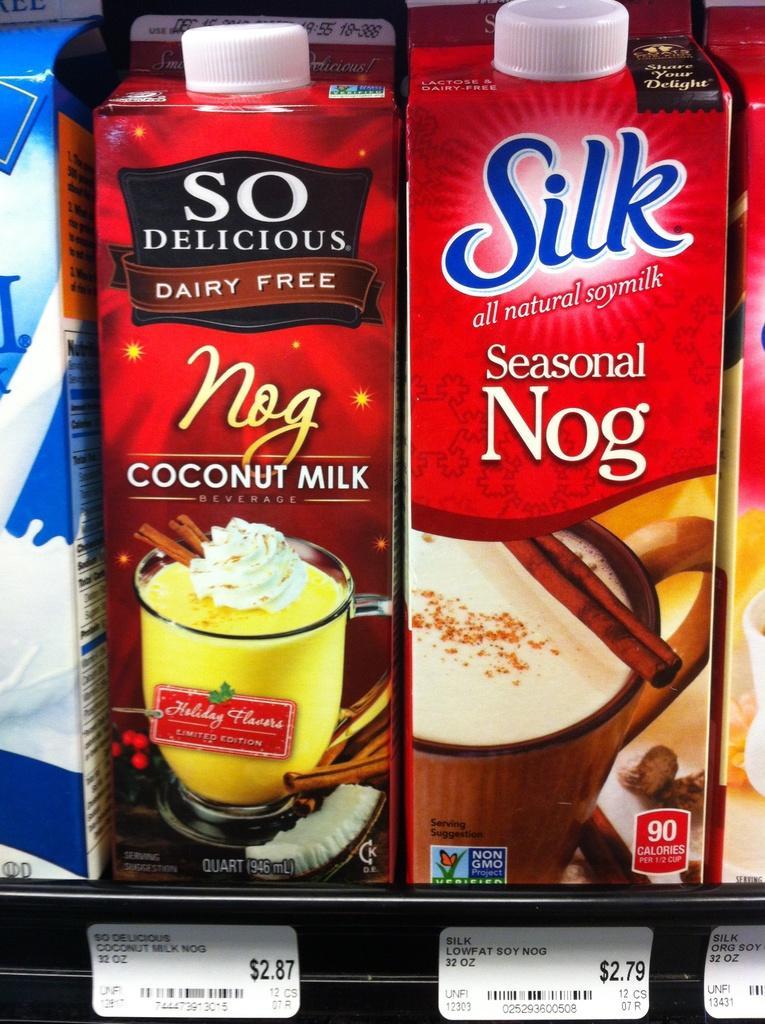Can you describe this image briefly? In this image we can see few tetra packs with some text and images on it, which are on the racks, also we can see cards with text on it. 